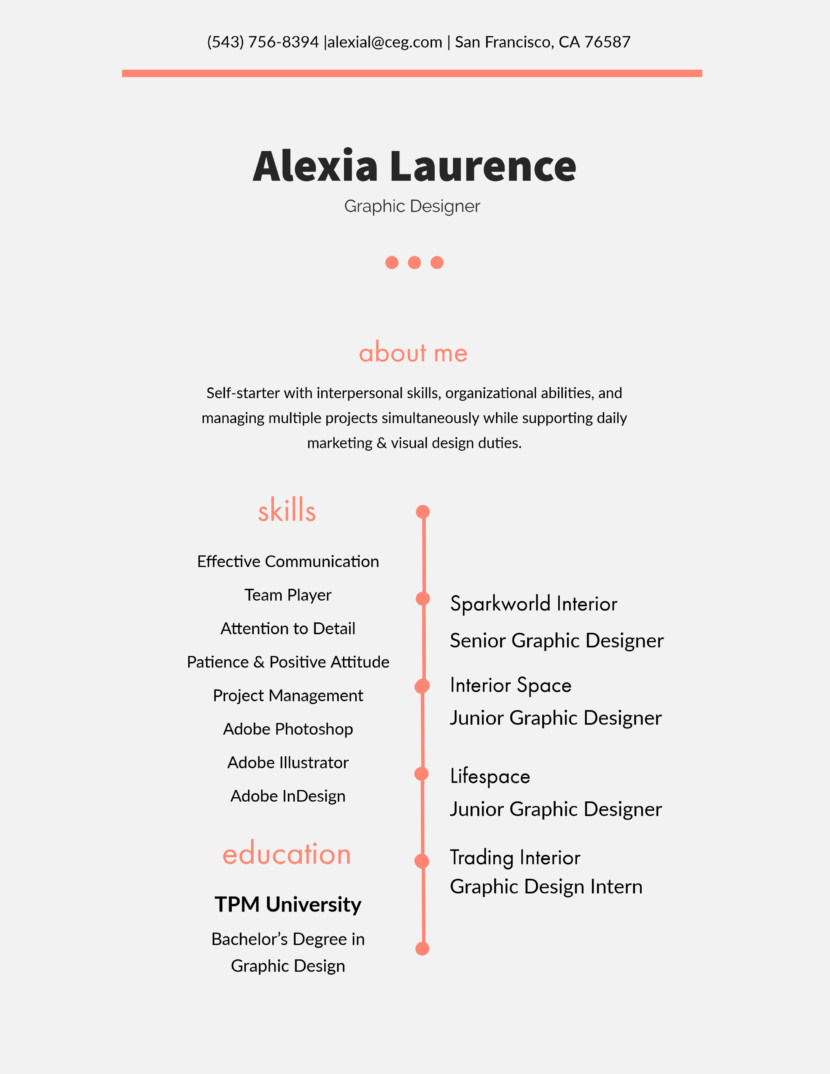What software skills listed on Alexia's resume seem most crucial for her role in Sparkworld Interior? The software skills that appear most crucial for her role at Sparkworld Interior include Adobe Photoshop, Illustrator, and InDesign. These tools are fundamental for graphic design, allowing for the creation and manipulation of complex visuals and layouts which are essential in her role as a Senior Graphic Designer. 